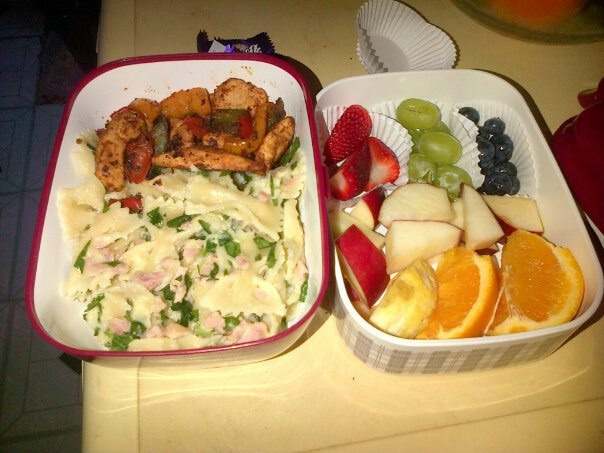Describe the objects in this image and their specific colors. I can see bowl in black, khaki, beige, maroon, and brown tones, bowl in black, tan, and orange tones, dining table in black, khaki, tan, and olive tones, apple in black, khaki, tan, and brown tones, and orange in black and orange tones in this image. 